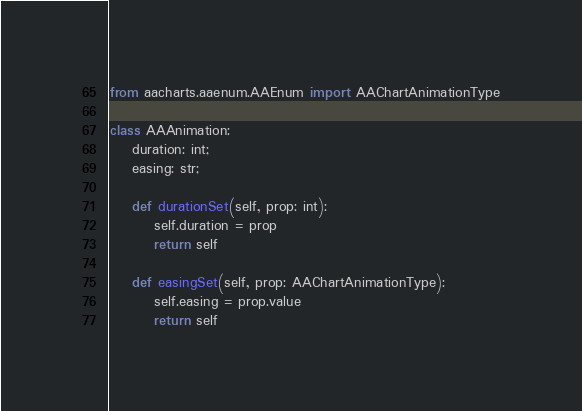<code> <loc_0><loc_0><loc_500><loc_500><_Python_>from aacharts.aaenum.AAEnum import AAChartAnimationType

class AAAnimation: 
    duration: int;
    easing: str;

    def durationSet(self, prop: int):
        self.duration = prop
        return self
    
    def easingSet(self, prop: AAChartAnimationType):
        self.easing = prop.value
        return self</code> 